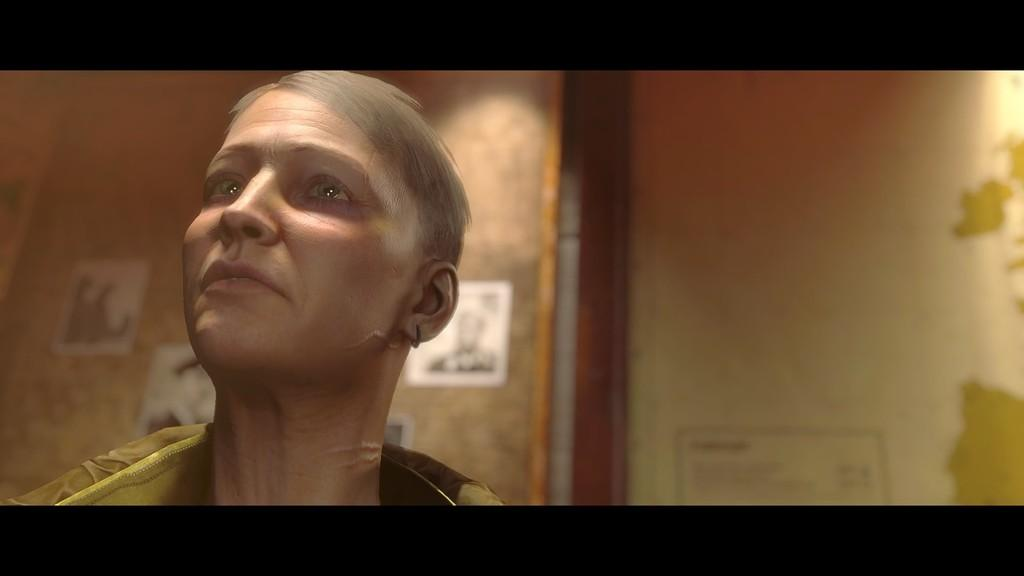Who or what is on the left side of the image? There is a person on the left side of the image. What can be seen in the background of the image? There is a wall and photographs in the background of the image. What type of chess pieces can be seen on the wall in the image? There is no chess or chess pieces visible in the image; only a wall and photographs are present. 